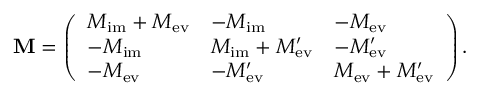Convert formula to latex. <formula><loc_0><loc_0><loc_500><loc_500>M = \left ( \begin{array} { l l l } { M _ { i m } + M _ { e v } } & { - M _ { i m } } & { - M _ { e v } } \\ { - M _ { i m } } & { M _ { i m } + M _ { e v } ^ { \prime } } & { - M _ { e v } ^ { \prime } } \\ { - M _ { e v } } & { - M _ { e v } ^ { \prime } } & { M _ { e v } + M _ { e v } ^ { \prime } } \end{array} \right ) .</formula> 